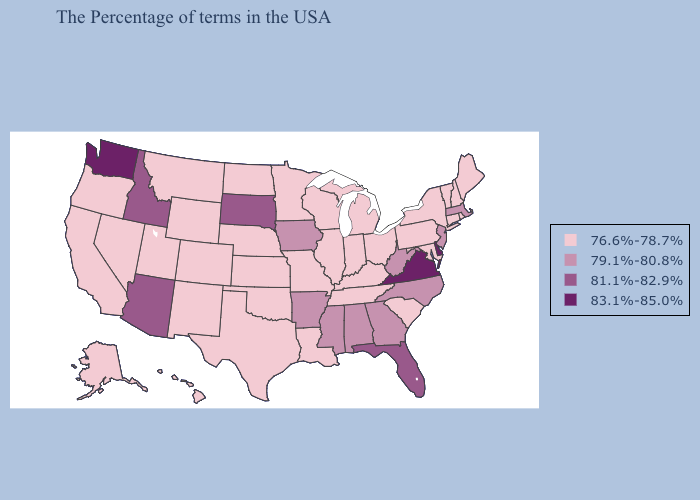Name the states that have a value in the range 79.1%-80.8%?
Quick response, please. Massachusetts, New Jersey, North Carolina, West Virginia, Georgia, Alabama, Mississippi, Arkansas, Iowa. Among the states that border Arkansas , does Louisiana have the highest value?
Answer briefly. No. Does New Jersey have the lowest value in the Northeast?
Concise answer only. No. What is the value of Alaska?
Concise answer only. 76.6%-78.7%. What is the lowest value in the Northeast?
Keep it brief. 76.6%-78.7%. Does the map have missing data?
Quick response, please. No. Does South Dakota have the highest value in the MidWest?
Write a very short answer. Yes. Name the states that have a value in the range 83.1%-85.0%?
Concise answer only. Delaware, Virginia, Washington. What is the lowest value in states that border Connecticut?
Be succinct. 76.6%-78.7%. Name the states that have a value in the range 81.1%-82.9%?
Give a very brief answer. Florida, South Dakota, Arizona, Idaho. Name the states that have a value in the range 79.1%-80.8%?
Be succinct. Massachusetts, New Jersey, North Carolina, West Virginia, Georgia, Alabama, Mississippi, Arkansas, Iowa. Which states have the lowest value in the South?
Answer briefly. Maryland, South Carolina, Kentucky, Tennessee, Louisiana, Oklahoma, Texas. Name the states that have a value in the range 81.1%-82.9%?
Be succinct. Florida, South Dakota, Arizona, Idaho. Does Delaware have the highest value in the South?
Keep it brief. Yes. 